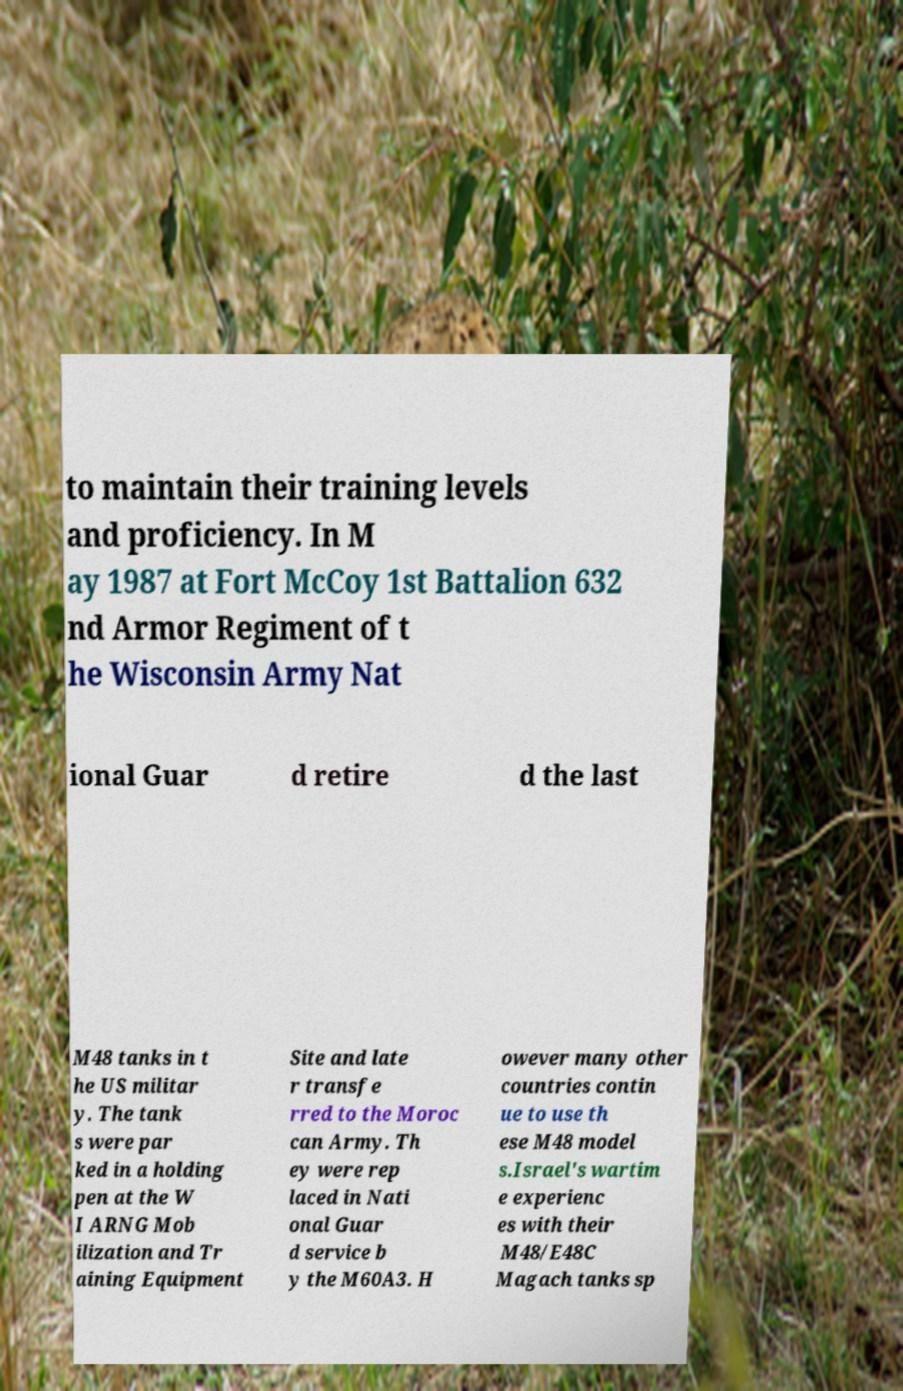Could you assist in decoding the text presented in this image and type it out clearly? to maintain their training levels and proficiency. In M ay 1987 at Fort McCoy 1st Battalion 632 nd Armor Regiment of t he Wisconsin Army Nat ional Guar d retire d the last M48 tanks in t he US militar y. The tank s were par ked in a holding pen at the W I ARNG Mob ilization and Tr aining Equipment Site and late r transfe rred to the Moroc can Army. Th ey were rep laced in Nati onal Guar d service b y the M60A3. H owever many other countries contin ue to use th ese M48 model s.Israel's wartim e experienc es with their M48/E48C Magach tanks sp 